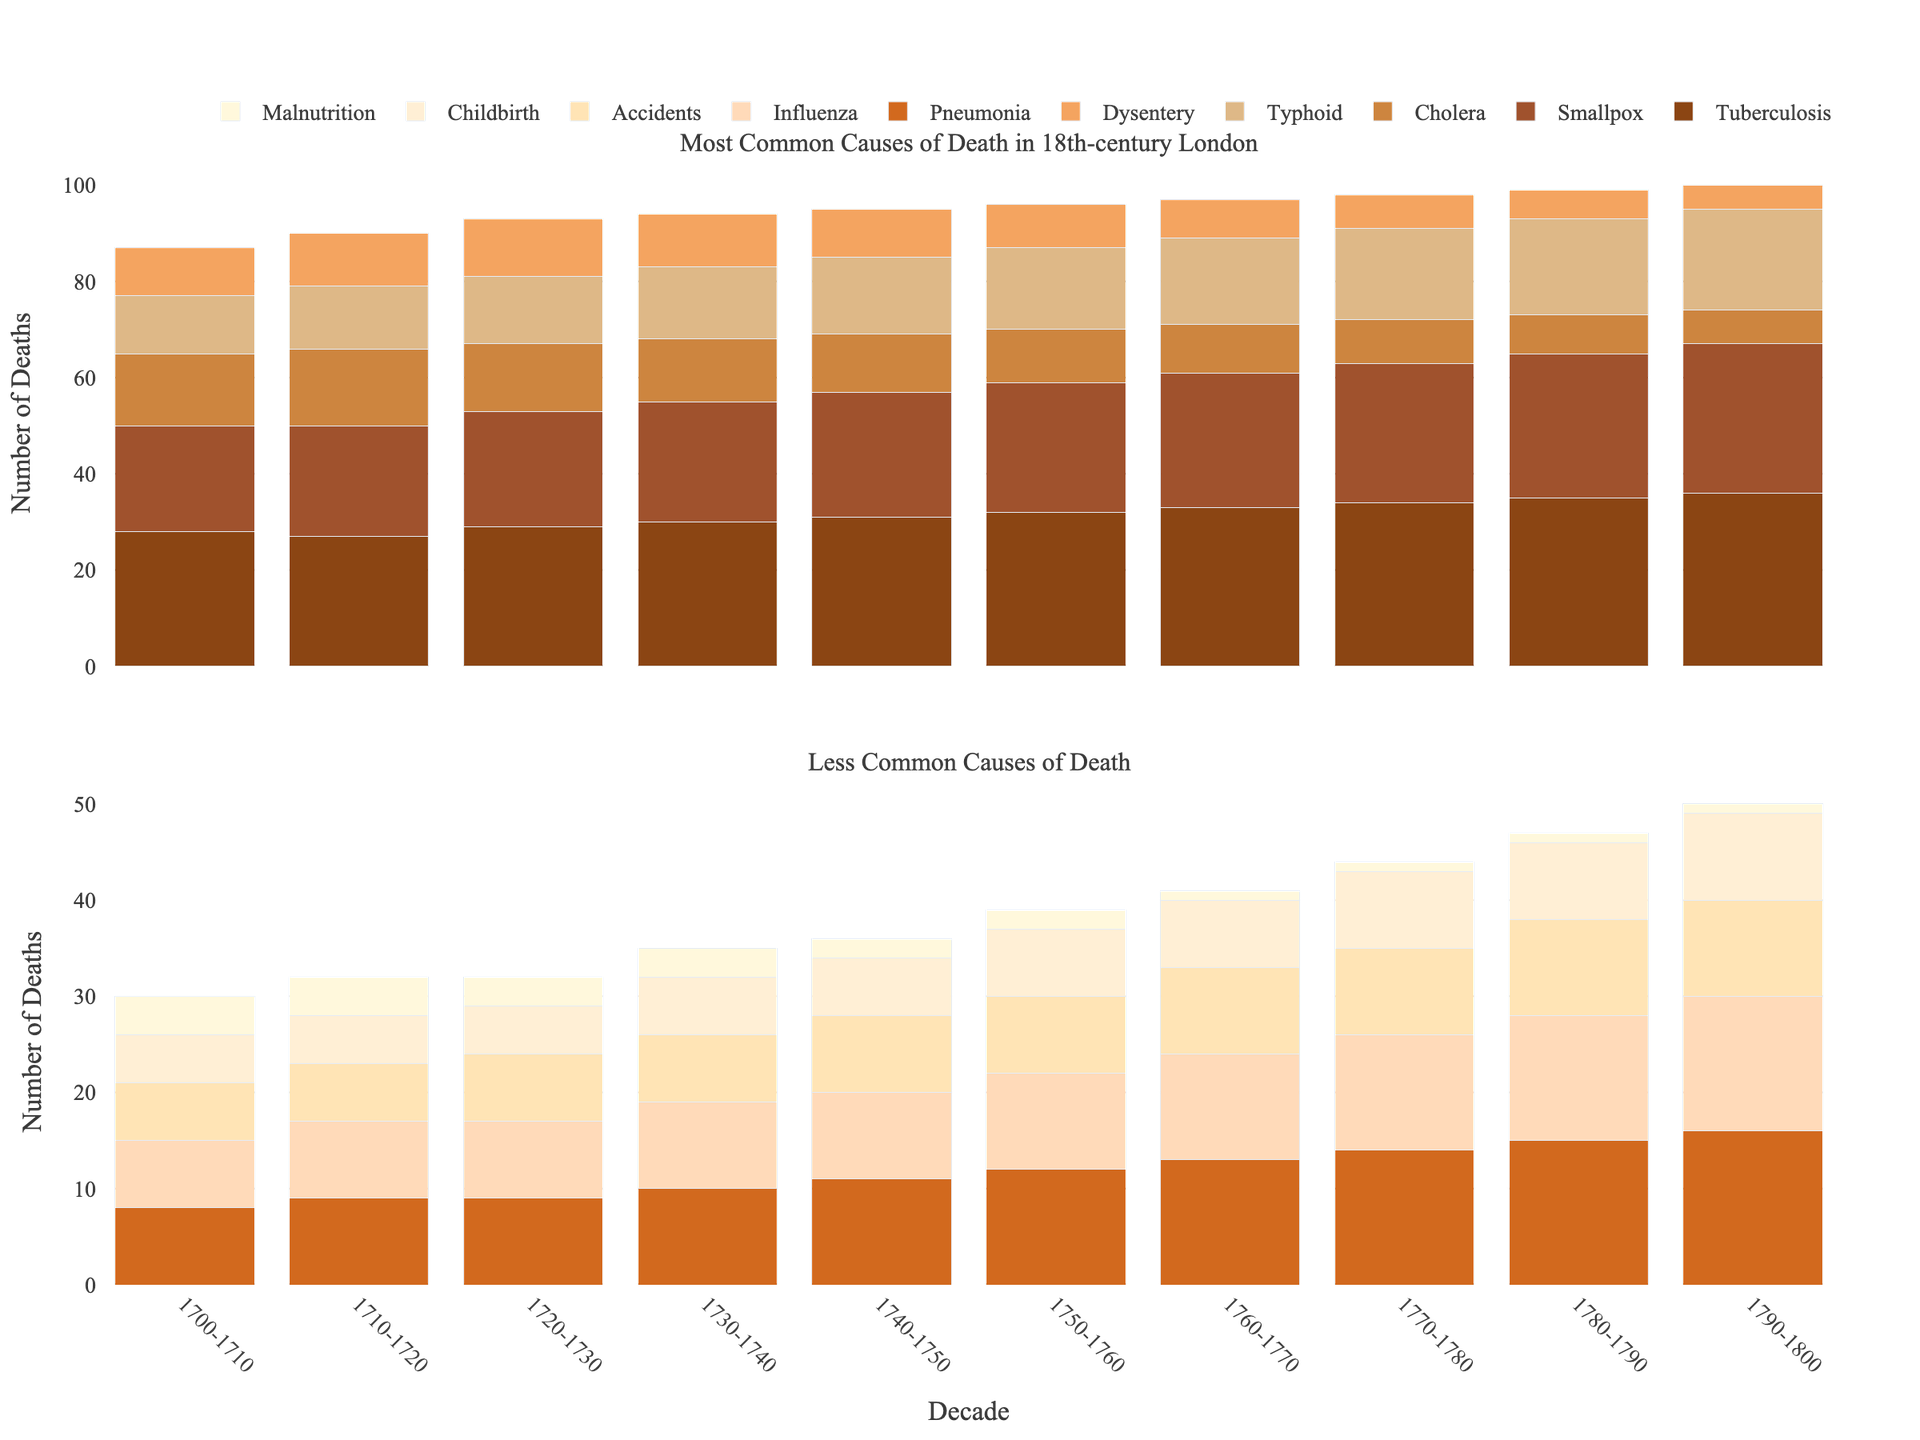Which decade saw the highest number of deaths from tuberculosis? The first subplot shows deaths from tuberculosis with each bar representing a decade. The decade with the tallest bar represents the highest number of deaths.
Answer: 1790-1800 Between which decades did deaths from cholera decrease the most? By examining the heights of the cholera bars in the first subplot, subtract the height of any pair of consecutive bars. The largest difference corresponds to the greatest decrease. The biggest drop appears between 1740-1750 (12) and 1790-1800 (7), especially between 1790-1800 which is continuously decreasing.
Answer: Between 1740-1750 and 1790-1800 In which decade did accidents surpass childbirth as a common cause of death? In the second subplot, compare the heights of the bars for accidents and childbirth across all decades. Identify the first decade where the accidents bar is taller than the childbirth bar.
Answer: 1720-1730 What is the total number of deaths from dysentery in the period 1760-1800? In the first subplot, sum the heights of the dysentery bars for the relevant decades: 1760-1770 (8), 1770-1780 (7), 1780-1790 (6), and 1790-1800 (5). The total is 8 + 7 + 6 + 5.
Answer: 26 What is the average number of deaths from influenza over the entire 18th century? In the second subplot, find the total number of deaths from influenza across all decades and then divide by 10. 7 + 8 + 8 + 9 + 9 + 10 + 11 + 12 + 13 + 14 divided by 10.
Answer: 10.1 How did the number of deaths from child malnutrition change from 1700-1710 to 1790-1800? In the second subplot, compare the heights of the bars for child malnutrition in 1700-1710 (4) and 1790-1800 (1). Subtract the latter value from the former to find the difference.
Answer: Decreased by 3 Which cause of death had the smallest increase in deaths over the century? For each cause of death, subtract the number of deaths in 1700-1710 from the number of deaths in 1790-1800 and identify the cause with the smallest difference. Color-coded bars provide a visual distinction. Causes: Smallest increase in smallpox from 22 to 31; Increase: 9, Difference: 9.
Answer: Pneumonia How does the sum of deaths from smallpox and typhoid in the decade 1750-1760 compare to the sum in 1790-1800? For each decade, add the heights of the bars for smallpox and typhoid: (1750-1760: 27 + 17) and (1790-1800: 31 + 21). Then compare the resulting sums.
Answer: 1750-1760 vs 1790-1800 -> 44 & 52; Increased When did pneumonia become a more common cause of death than dysentery? Compare the bar heights for pneumonia and dysentery in the first and second subplots for each decade. Identify the first decade when the pneumonia bar becomes taller than the dysentery bar.
Answer: 1730-1740 Which two causes had the closest numbers of deaths in 1780-1790? In the subplots, examine the bar heights for all causes in 1780-1790. Identify the two causes with the least difference in their heights. Smallpox and Influenza close gap in 1780-1790, (30 & 20) vs (9 & 10).
Answer: Smallpox & Influenza 